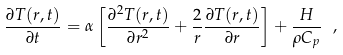<formula> <loc_0><loc_0><loc_500><loc_500>\frac { \partial { T ( r , t ) } } { \partial { t } } = \alpha \left [ \frac { \partial ^ { 2 } T ( r , t ) } { \partial r ^ { 2 } } + \frac { 2 } { r } \frac { \partial T ( r , t ) } { \partial r } \right ] + \frac { H } { \rho C _ { p } } \ ,</formula> 